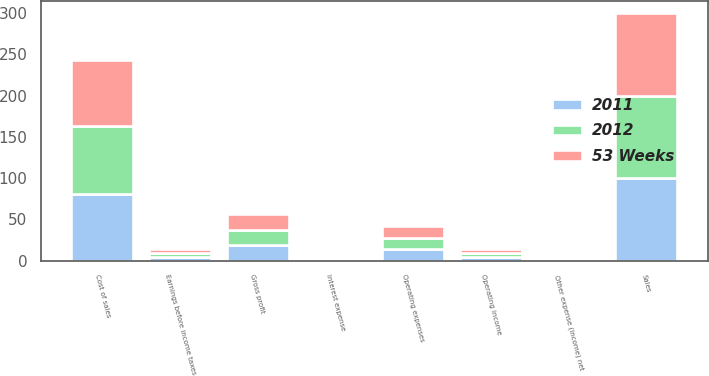Convert chart to OTSL. <chart><loc_0><loc_0><loc_500><loc_500><stacked_bar_chart><ecel><fcel>Sales<fcel>Cost of sales<fcel>Gross profit<fcel>Operating expenses<fcel>Operating income<fcel>Interest expense<fcel>Other expense (income) net<fcel>Earnings before income taxes<nl><fcel>2012<fcel>100<fcel>81.9<fcel>18.1<fcel>13.6<fcel>4.5<fcel>0.3<fcel>0<fcel>4.2<nl><fcel>2011<fcel>100<fcel>81.2<fcel>18.8<fcel>13.9<fcel>4.9<fcel>0.3<fcel>0<fcel>4.6<nl><fcel>53 Weeks<fcel>100<fcel>80.7<fcel>19.3<fcel>14<fcel>5.3<fcel>0.3<fcel>0<fcel>5<nl></chart> 